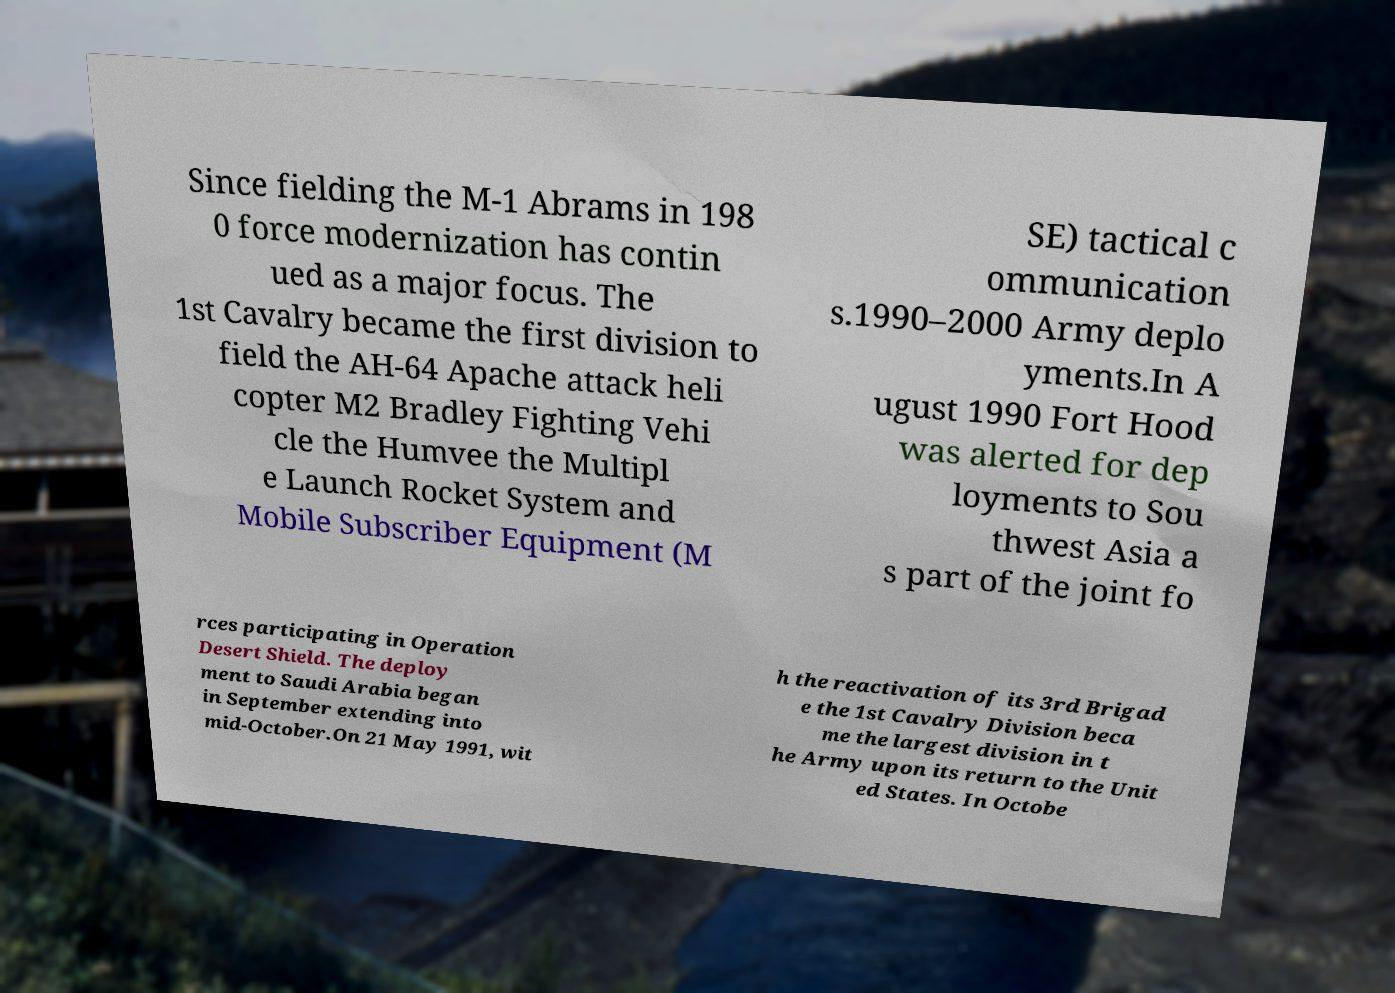What messages or text are displayed in this image? I need them in a readable, typed format. Since fielding the M-1 Abrams in 198 0 force modernization has contin ued as a major focus. The 1st Cavalry became the first division to field the AH-64 Apache attack heli copter M2 Bradley Fighting Vehi cle the Humvee the Multipl e Launch Rocket System and Mobile Subscriber Equipment (M SE) tactical c ommunication s.1990–2000 Army deplo yments.In A ugust 1990 Fort Hood was alerted for dep loyments to Sou thwest Asia a s part of the joint fo rces participating in Operation Desert Shield. The deploy ment to Saudi Arabia began in September extending into mid-October.On 21 May 1991, wit h the reactivation of its 3rd Brigad e the 1st Cavalry Division beca me the largest division in t he Army upon its return to the Unit ed States. In Octobe 